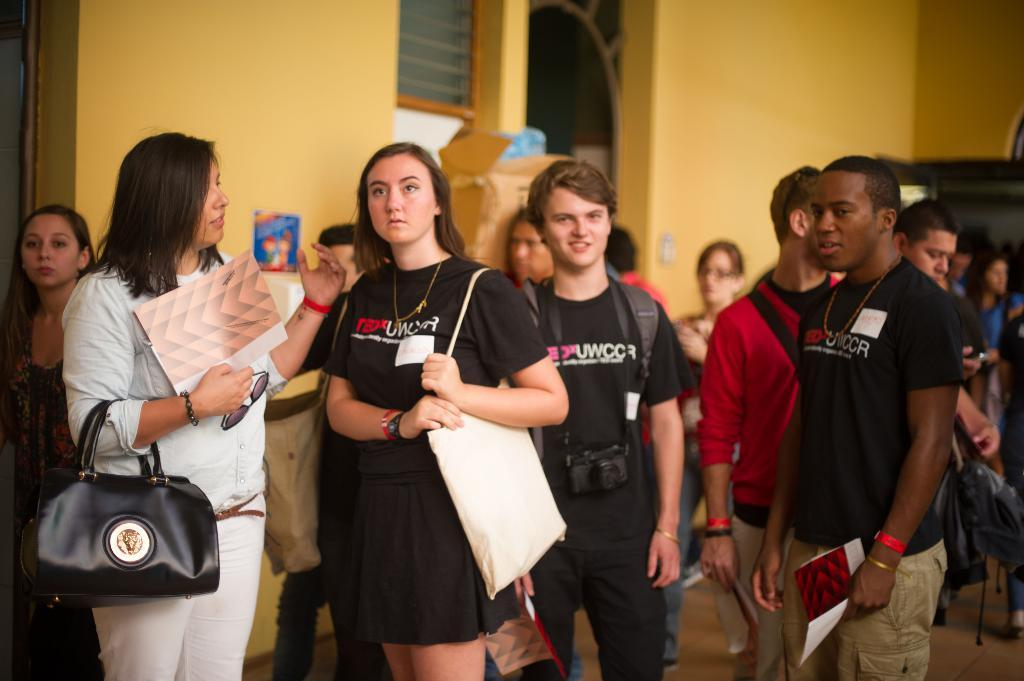What is the main subject of the image? The main subject of the image is a group of people. What are the people in the image doing? The people are standing in the image. What items are the people holding in the image? The people are holding backpacks and papers in their hands. Can you see any fairies flying around the people in the image? No, there are no fairies present in the image. What is the reason for the people holding their backpacks in the image? The provided facts do not give any information about the reason for the people holding their backpacks, so we cannot determine the reason from the image. 